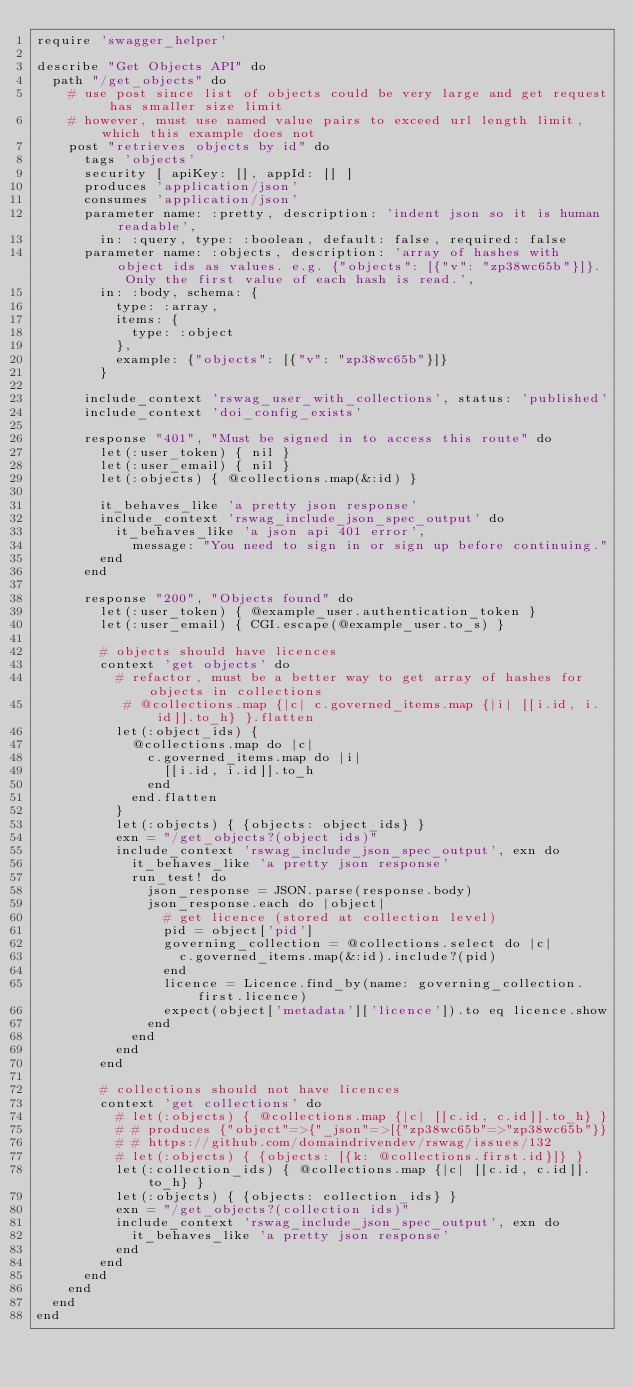<code> <loc_0><loc_0><loc_500><loc_500><_Ruby_>require 'swagger_helper'

describe "Get Objects API" do
  path "/get_objects" do
    # use post since list of objects could be very large and get request has smaller size limit
    # however, must use named value pairs to exceed url length limit, which this example does not
    post "retrieves objects by id" do
      tags 'objects'
      security [ apiKey: [], appId: [] ]
      produces 'application/json'
      consumes 'application/json'
      parameter name: :pretty, description: 'indent json so it is human readable', 
        in: :query, type: :boolean, default: false, required: false
      parameter name: :objects, description: 'array of hashes with object ids as values. e.g. {"objects": [{"v": "zp38wc65b"}]}. Only the first value of each hash is read.',
        in: :body, schema: {
          type: :array,
          items: {
            type: :object
          },
          example: {"objects": [{"v": "zp38wc65b"}]}
        }

      include_context 'rswag_user_with_collections', status: 'published'
      include_context 'doi_config_exists'

      response "401", "Must be signed in to access this route" do
        let(:user_token) { nil }
        let(:user_email) { nil }
        let(:objects) { @collections.map(&:id) }

        it_behaves_like 'a pretty json response'
        include_context 'rswag_include_json_spec_output' do
          it_behaves_like 'a json api 401 error',
            message: "You need to sign in or sign up before continuing."
        end
      end

      response "200", "Objects found" do
        let(:user_token) { @example_user.authentication_token }
        let(:user_email) { CGI.escape(@example_user.to_s) }

        # objects should have licences
        context 'get objects' do
          # refactor, must be a better way to get array of hashes for objects in collections
           # @collections.map {|c| c.governed_items.map {|i| [[i.id, i.id]].to_h} }.flatten
          let(:object_ids) {
            @collections.map do |c| 
              c.governed_items.map do |i| 
                [[i.id, i.id]].to_h
              end
            end.flatten
          }
          let(:objects) { {objects: object_ids} }
          exn = "/get_objects?(object ids)"
          include_context 'rswag_include_json_spec_output', exn do
            it_behaves_like 'a pretty json response'
            run_test! do
              json_response = JSON.parse(response.body)
              json_response.each do |object|
                # get licence (stored at collection level)
                pid = object['pid']
                governing_collection = @collections.select do |c| 
                  c.governed_items.map(&:id).include?(pid)
                end
                licence = Licence.find_by(name: governing_collection.first.licence)
                expect(object['metadata']['licence']).to eq licence.show
              end
            end
          end
        end

        # collections should not have licences
        context 'get collections' do
          # let(:objects) { @collections.map {|c| [[c.id, c.id]].to_h} }
          # # produces {"object"=>{"_json"=>[{"zp38wc65b"=>"zp38wc65b"}}
          # # https://github.com/domaindrivendev/rswag/issues/132
          # let(:objects) { {objects: [{k: @collections.first.id}]} }
          let(:collection_ids) { @collections.map {|c| [[c.id, c.id]].to_h} }
          let(:objects) { {objects: collection_ids} }
          exn = "/get_objects?(collection ids)"
          include_context 'rswag_include_json_spec_output', exn do
            it_behaves_like 'a pretty json response'
          end
        end
      end
    end
  end
end
</code> 